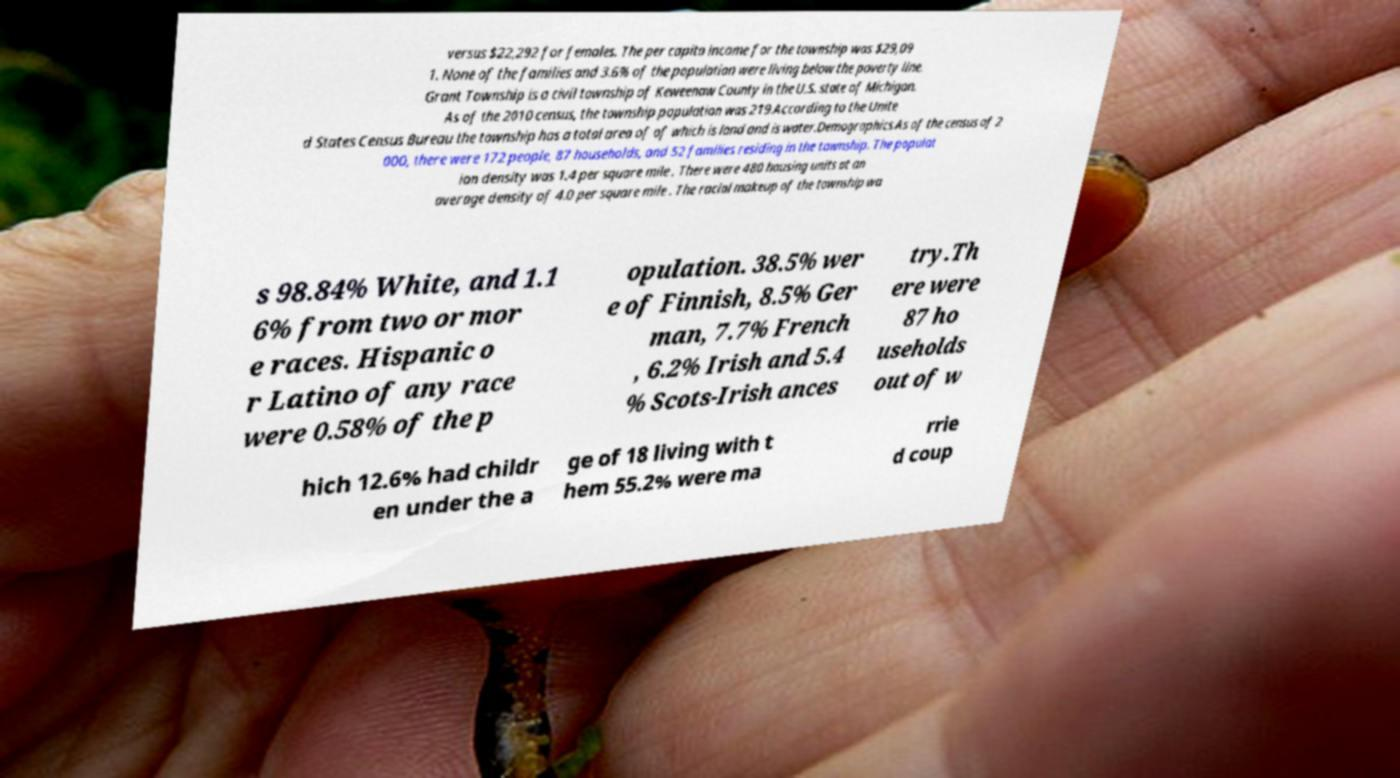Can you accurately transcribe the text from the provided image for me? versus $22,292 for females. The per capita income for the township was $29,09 1. None of the families and 3.6% of the population were living below the poverty line. Grant Township is a civil township of Keweenaw County in the U.S. state of Michigan. As of the 2010 census, the township population was 219.According to the Unite d States Census Bureau the township has a total area of of which is land and is water.Demographics.As of the census of 2 000, there were 172 people, 87 households, and 52 families residing in the township. The populat ion density was 1.4 per square mile . There were 480 housing units at an average density of 4.0 per square mile . The racial makeup of the township wa s 98.84% White, and 1.1 6% from two or mor e races. Hispanic o r Latino of any race were 0.58% of the p opulation. 38.5% wer e of Finnish, 8.5% Ger man, 7.7% French , 6.2% Irish and 5.4 % Scots-Irish ances try.Th ere were 87 ho useholds out of w hich 12.6% had childr en under the a ge of 18 living with t hem 55.2% were ma rrie d coup 